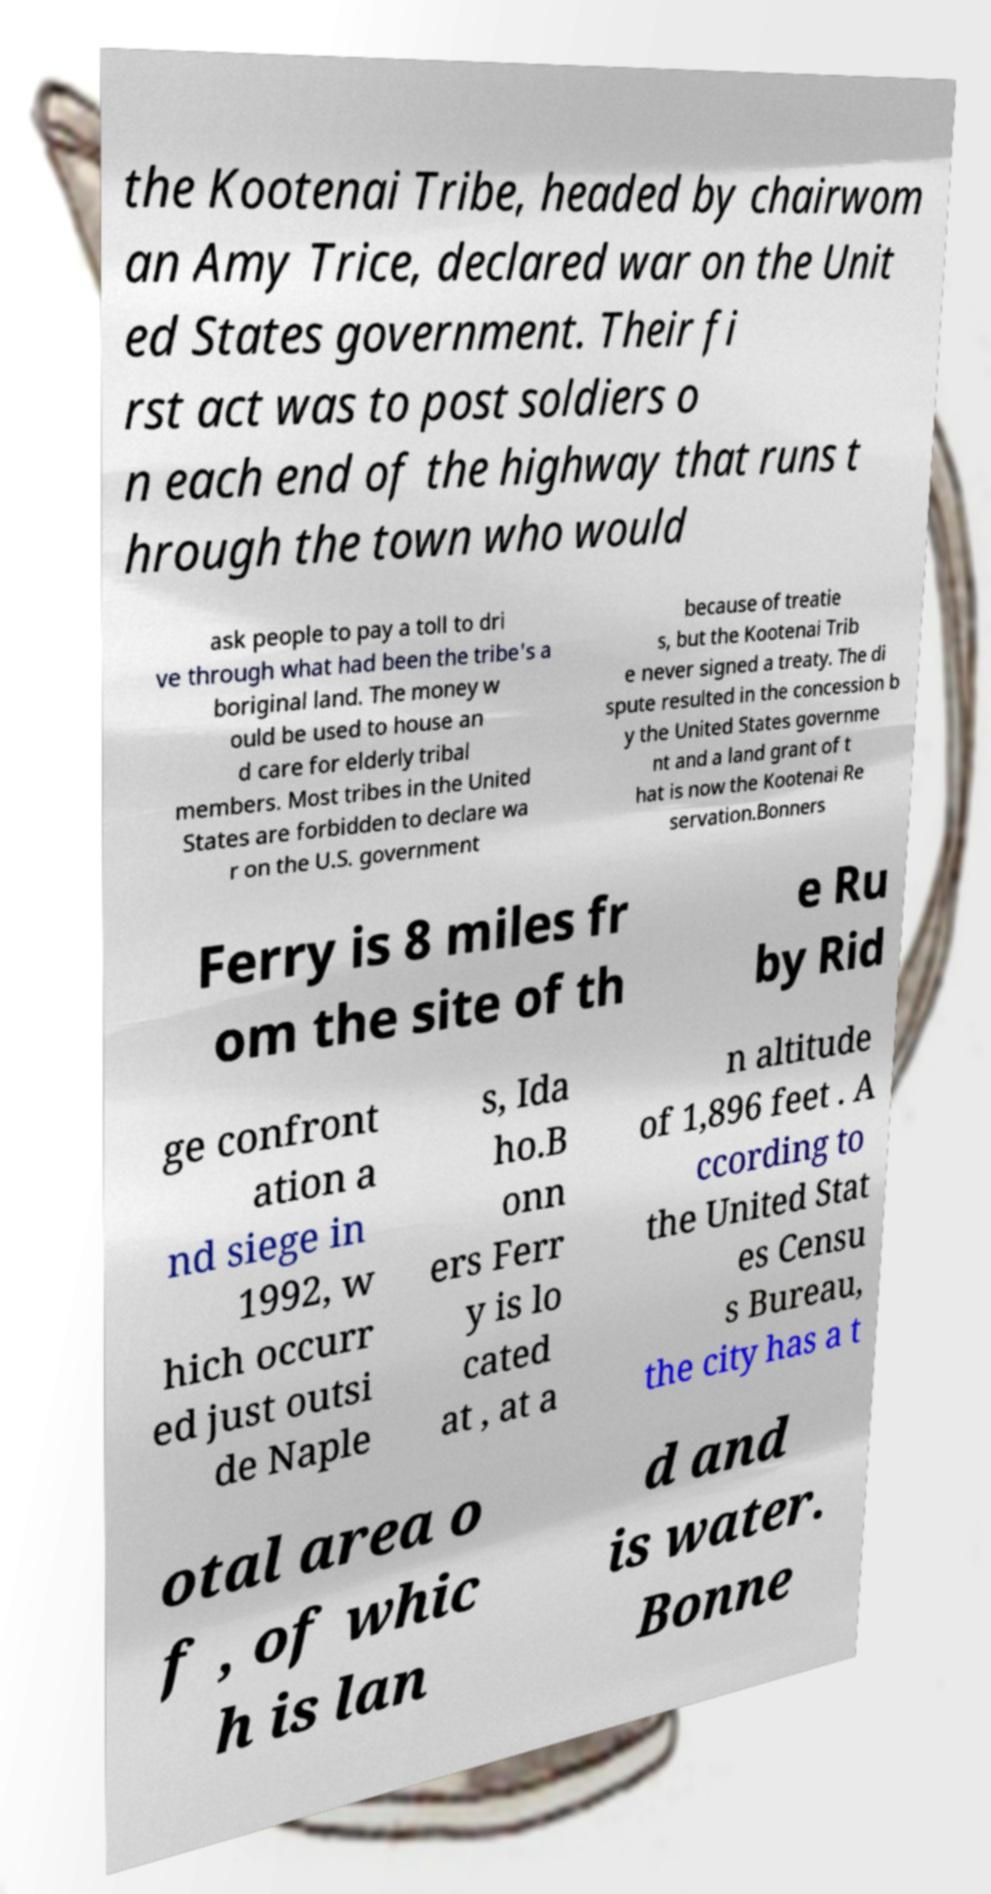What messages or text are displayed in this image? I need them in a readable, typed format. the Kootenai Tribe, headed by chairwom an Amy Trice, declared war on the Unit ed States government. Their fi rst act was to post soldiers o n each end of the highway that runs t hrough the town who would ask people to pay a toll to dri ve through what had been the tribe's a boriginal land. The money w ould be used to house an d care for elderly tribal members. Most tribes in the United States are forbidden to declare wa r on the U.S. government because of treatie s, but the Kootenai Trib e never signed a treaty. The di spute resulted in the concession b y the United States governme nt and a land grant of t hat is now the Kootenai Re servation.Bonners Ferry is 8 miles fr om the site of th e Ru by Rid ge confront ation a nd siege in 1992, w hich occurr ed just outsi de Naple s, Ida ho.B onn ers Ferr y is lo cated at , at a n altitude of 1,896 feet . A ccording to the United Stat es Censu s Bureau, the city has a t otal area o f , of whic h is lan d and is water. Bonne 